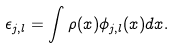Convert formula to latex. <formula><loc_0><loc_0><loc_500><loc_500>\epsilon _ { j , l } = \int \rho ( x ) \phi _ { j , l } ( x ) d x .</formula> 